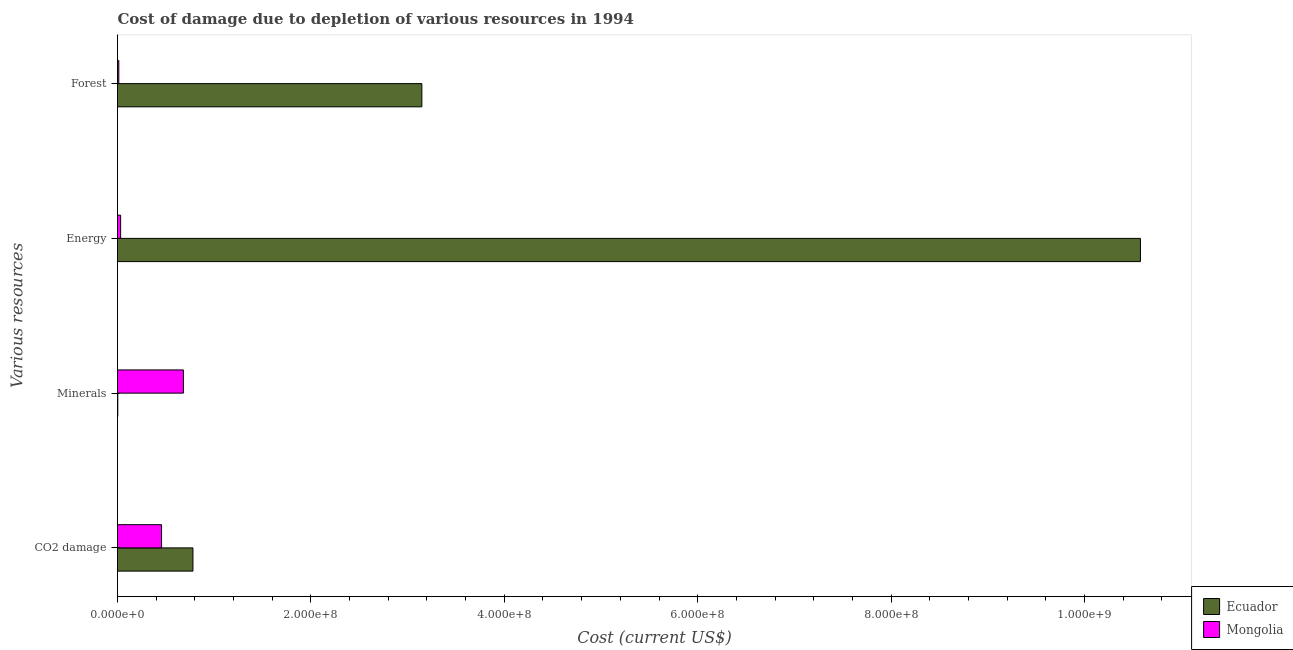What is the label of the 4th group of bars from the top?
Ensure brevity in your answer.  CO2 damage. What is the cost of damage due to depletion of forests in Ecuador?
Your response must be concise. 3.15e+08. Across all countries, what is the maximum cost of damage due to depletion of energy?
Offer a very short reply. 1.06e+09. Across all countries, what is the minimum cost of damage due to depletion of energy?
Provide a succinct answer. 3.22e+06. In which country was the cost of damage due to depletion of coal maximum?
Make the answer very short. Ecuador. In which country was the cost of damage due to depletion of coal minimum?
Offer a very short reply. Mongolia. What is the total cost of damage due to depletion of minerals in the graph?
Your answer should be compact. 6.84e+07. What is the difference between the cost of damage due to depletion of coal in Ecuador and that in Mongolia?
Offer a very short reply. 3.25e+07. What is the difference between the cost of damage due to depletion of forests in Ecuador and the cost of damage due to depletion of energy in Mongolia?
Ensure brevity in your answer.  3.12e+08. What is the average cost of damage due to depletion of coal per country?
Offer a very short reply. 6.18e+07. What is the difference between the cost of damage due to depletion of energy and cost of damage due to depletion of coal in Ecuador?
Give a very brief answer. 9.80e+08. What is the ratio of the cost of damage due to depletion of energy in Mongolia to that in Ecuador?
Keep it short and to the point. 0. What is the difference between the highest and the second highest cost of damage due to depletion of minerals?
Keep it short and to the point. 6.78e+07. What is the difference between the highest and the lowest cost of damage due to depletion of minerals?
Make the answer very short. 6.78e+07. Is the sum of the cost of damage due to depletion of minerals in Mongolia and Ecuador greater than the maximum cost of damage due to depletion of coal across all countries?
Your response must be concise. No. What does the 1st bar from the top in Forest represents?
Keep it short and to the point. Mongolia. What does the 1st bar from the bottom in CO2 damage represents?
Offer a very short reply. Ecuador. How many bars are there?
Your answer should be compact. 8. Are all the bars in the graph horizontal?
Your answer should be very brief. Yes. What is the difference between two consecutive major ticks on the X-axis?
Your response must be concise. 2.00e+08. Does the graph contain any zero values?
Provide a short and direct response. No. Does the graph contain grids?
Provide a succinct answer. No. Where does the legend appear in the graph?
Offer a very short reply. Bottom right. How many legend labels are there?
Your answer should be compact. 2. How are the legend labels stacked?
Keep it short and to the point. Vertical. What is the title of the graph?
Offer a terse response. Cost of damage due to depletion of various resources in 1994 . Does "Latin America(all income levels)" appear as one of the legend labels in the graph?
Your response must be concise. No. What is the label or title of the X-axis?
Your response must be concise. Cost (current US$). What is the label or title of the Y-axis?
Give a very brief answer. Various resources. What is the Cost (current US$) of Ecuador in CO2 damage?
Make the answer very short. 7.80e+07. What is the Cost (current US$) in Mongolia in CO2 damage?
Provide a short and direct response. 4.55e+07. What is the Cost (current US$) in Ecuador in Minerals?
Make the answer very short. 3.01e+05. What is the Cost (current US$) in Mongolia in Minerals?
Offer a very short reply. 6.81e+07. What is the Cost (current US$) of Ecuador in Energy?
Make the answer very short. 1.06e+09. What is the Cost (current US$) of Mongolia in Energy?
Offer a very short reply. 3.22e+06. What is the Cost (current US$) in Ecuador in Forest?
Your response must be concise. 3.15e+08. What is the Cost (current US$) in Mongolia in Forest?
Offer a very short reply. 1.35e+06. Across all Various resources, what is the maximum Cost (current US$) of Ecuador?
Provide a short and direct response. 1.06e+09. Across all Various resources, what is the maximum Cost (current US$) of Mongolia?
Offer a very short reply. 6.81e+07. Across all Various resources, what is the minimum Cost (current US$) in Ecuador?
Provide a short and direct response. 3.01e+05. Across all Various resources, what is the minimum Cost (current US$) in Mongolia?
Provide a succinct answer. 1.35e+06. What is the total Cost (current US$) of Ecuador in the graph?
Provide a short and direct response. 1.45e+09. What is the total Cost (current US$) of Mongolia in the graph?
Provide a succinct answer. 1.18e+08. What is the difference between the Cost (current US$) of Ecuador in CO2 damage and that in Minerals?
Keep it short and to the point. 7.77e+07. What is the difference between the Cost (current US$) of Mongolia in CO2 damage and that in Minerals?
Your response must be concise. -2.26e+07. What is the difference between the Cost (current US$) in Ecuador in CO2 damage and that in Energy?
Offer a very short reply. -9.80e+08. What is the difference between the Cost (current US$) of Mongolia in CO2 damage and that in Energy?
Make the answer very short. 4.23e+07. What is the difference between the Cost (current US$) of Ecuador in CO2 damage and that in Forest?
Your response must be concise. -2.37e+08. What is the difference between the Cost (current US$) in Mongolia in CO2 damage and that in Forest?
Ensure brevity in your answer.  4.42e+07. What is the difference between the Cost (current US$) of Ecuador in Minerals and that in Energy?
Offer a terse response. -1.06e+09. What is the difference between the Cost (current US$) of Mongolia in Minerals and that in Energy?
Your response must be concise. 6.49e+07. What is the difference between the Cost (current US$) in Ecuador in Minerals and that in Forest?
Give a very brief answer. -3.14e+08. What is the difference between the Cost (current US$) in Mongolia in Minerals and that in Forest?
Your answer should be compact. 6.68e+07. What is the difference between the Cost (current US$) in Ecuador in Energy and that in Forest?
Offer a terse response. 7.43e+08. What is the difference between the Cost (current US$) in Mongolia in Energy and that in Forest?
Your answer should be compact. 1.87e+06. What is the difference between the Cost (current US$) of Ecuador in CO2 damage and the Cost (current US$) of Mongolia in Minerals?
Offer a terse response. 9.88e+06. What is the difference between the Cost (current US$) of Ecuador in CO2 damage and the Cost (current US$) of Mongolia in Energy?
Provide a short and direct response. 7.48e+07. What is the difference between the Cost (current US$) in Ecuador in CO2 damage and the Cost (current US$) in Mongolia in Forest?
Offer a terse response. 7.67e+07. What is the difference between the Cost (current US$) of Ecuador in Minerals and the Cost (current US$) of Mongolia in Energy?
Provide a succinct answer. -2.92e+06. What is the difference between the Cost (current US$) in Ecuador in Minerals and the Cost (current US$) in Mongolia in Forest?
Your answer should be very brief. -1.05e+06. What is the difference between the Cost (current US$) of Ecuador in Energy and the Cost (current US$) of Mongolia in Forest?
Give a very brief answer. 1.06e+09. What is the average Cost (current US$) in Ecuador per Various resources?
Your response must be concise. 3.63e+08. What is the average Cost (current US$) of Mongolia per Various resources?
Your answer should be very brief. 2.96e+07. What is the difference between the Cost (current US$) in Ecuador and Cost (current US$) in Mongolia in CO2 damage?
Provide a succinct answer. 3.25e+07. What is the difference between the Cost (current US$) in Ecuador and Cost (current US$) in Mongolia in Minerals?
Your response must be concise. -6.78e+07. What is the difference between the Cost (current US$) in Ecuador and Cost (current US$) in Mongolia in Energy?
Your answer should be compact. 1.05e+09. What is the difference between the Cost (current US$) of Ecuador and Cost (current US$) of Mongolia in Forest?
Offer a very short reply. 3.13e+08. What is the ratio of the Cost (current US$) of Ecuador in CO2 damage to that in Minerals?
Ensure brevity in your answer.  258.98. What is the ratio of the Cost (current US$) in Mongolia in CO2 damage to that in Minerals?
Ensure brevity in your answer.  0.67. What is the ratio of the Cost (current US$) in Ecuador in CO2 damage to that in Energy?
Make the answer very short. 0.07. What is the ratio of the Cost (current US$) of Mongolia in CO2 damage to that in Energy?
Your answer should be compact. 14.15. What is the ratio of the Cost (current US$) of Ecuador in CO2 damage to that in Forest?
Provide a short and direct response. 0.25. What is the ratio of the Cost (current US$) in Mongolia in CO2 damage to that in Forest?
Make the answer very short. 33.67. What is the ratio of the Cost (current US$) of Ecuador in Minerals to that in Energy?
Give a very brief answer. 0. What is the ratio of the Cost (current US$) of Mongolia in Minerals to that in Energy?
Your response must be concise. 21.17. What is the ratio of the Cost (current US$) of Mongolia in Minerals to that in Forest?
Offer a terse response. 50.37. What is the ratio of the Cost (current US$) of Ecuador in Energy to that in Forest?
Give a very brief answer. 3.36. What is the ratio of the Cost (current US$) of Mongolia in Energy to that in Forest?
Make the answer very short. 2.38. What is the difference between the highest and the second highest Cost (current US$) of Ecuador?
Ensure brevity in your answer.  7.43e+08. What is the difference between the highest and the second highest Cost (current US$) of Mongolia?
Provide a short and direct response. 2.26e+07. What is the difference between the highest and the lowest Cost (current US$) of Ecuador?
Ensure brevity in your answer.  1.06e+09. What is the difference between the highest and the lowest Cost (current US$) of Mongolia?
Give a very brief answer. 6.68e+07. 